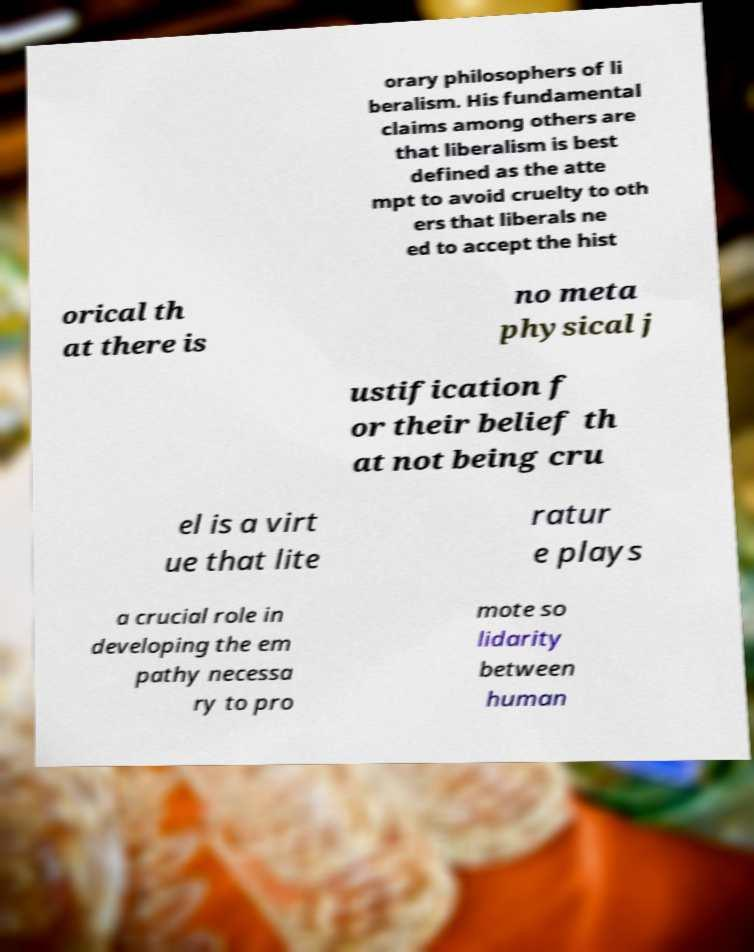Could you assist in decoding the text presented in this image and type it out clearly? orary philosophers of li beralism. His fundamental claims among others are that liberalism is best defined as the atte mpt to avoid cruelty to oth ers that liberals ne ed to accept the hist orical th at there is no meta physical j ustification f or their belief th at not being cru el is a virt ue that lite ratur e plays a crucial role in developing the em pathy necessa ry to pro mote so lidarity between human 